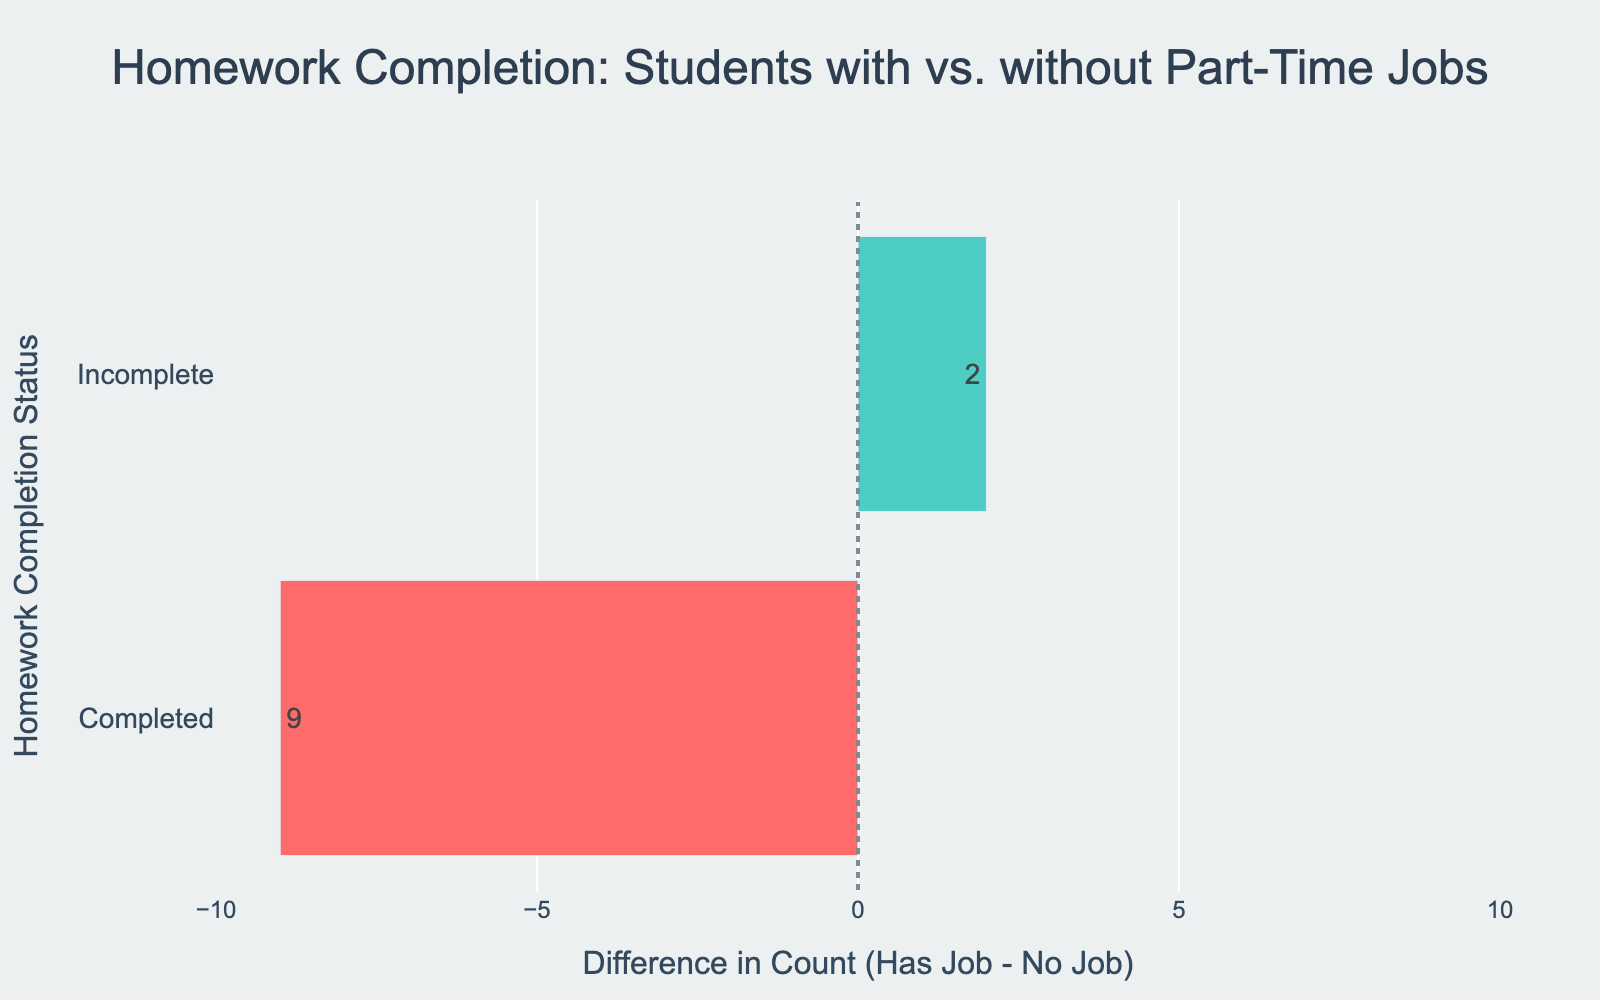What's the difference in counts of homework completion between students with part-time jobs and those without for the "Completed" status? To find the difference, subtract the count of students without part-time jobs who completed their homework (24) from the count of students with part-time jobs who completed their homework (15). The calculation is 15 - 24 which equals -9.
Answer: -9 Which group has a higher count of incomplete homework, students with part-time jobs or those without? By comparing the counts, students with part-time jobs have 8 incomplete, while those without part-time jobs have 6 incomplete. 8 is greater than 6.
Answer: Students with part-time jobs What color represents a positive difference in the bar chart? Positive differences are shown in green, as indicated by the diverging bar chart color encoding.
Answer: Green What's the total count of students with incomplete homework? Add the counts of students with incomplete homework both with and without part-time jobs. The calculation is 8 + 6.
Answer: 14 How does the count of completed homework differ between students with part-time jobs and those without? Subtract the count of completed homework for students with jobs (15) from those without jobs (24). The calculation is 24 - 15 which equals 9.
Answer: 9 What's the overall difference in homework completion between students with and without part-time jobs based on the visual? The difference for 'Completed' homework is -9 and 'Incomplete' is 2. Adding them together: -9 (for completed) and 2 (for incomplete). The net difference is -7.
Answer: -7 